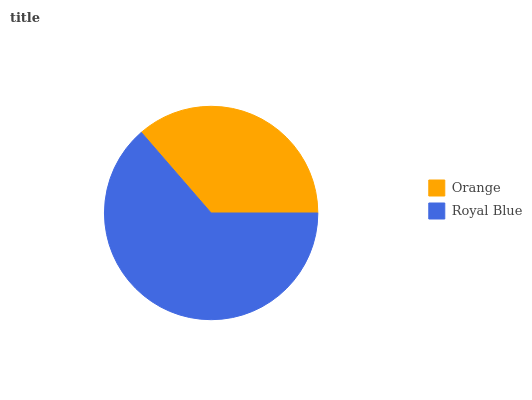Is Orange the minimum?
Answer yes or no. Yes. Is Royal Blue the maximum?
Answer yes or no. Yes. Is Royal Blue the minimum?
Answer yes or no. No. Is Royal Blue greater than Orange?
Answer yes or no. Yes. Is Orange less than Royal Blue?
Answer yes or no. Yes. Is Orange greater than Royal Blue?
Answer yes or no. No. Is Royal Blue less than Orange?
Answer yes or no. No. Is Royal Blue the high median?
Answer yes or no. Yes. Is Orange the low median?
Answer yes or no. Yes. Is Orange the high median?
Answer yes or no. No. Is Royal Blue the low median?
Answer yes or no. No. 